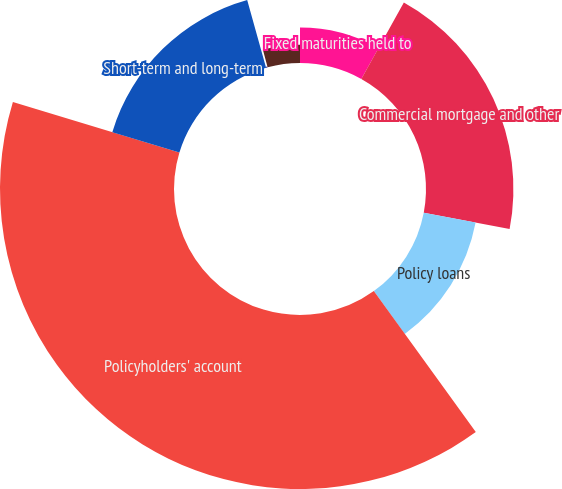Convert chart. <chart><loc_0><loc_0><loc_500><loc_500><pie_chart><fcel>Fixed maturities held to<fcel>Commercial mortgage and other<fcel>Policy loans<fcel>Policyholders' account<fcel>Short-term and long-term<fcel>Debt of consolidated VIEs<fcel>Bank customer liabilities<nl><fcel>8.09%<fcel>19.92%<fcel>12.03%<fcel>39.65%<fcel>15.98%<fcel>0.2%<fcel>4.14%<nl></chart> 